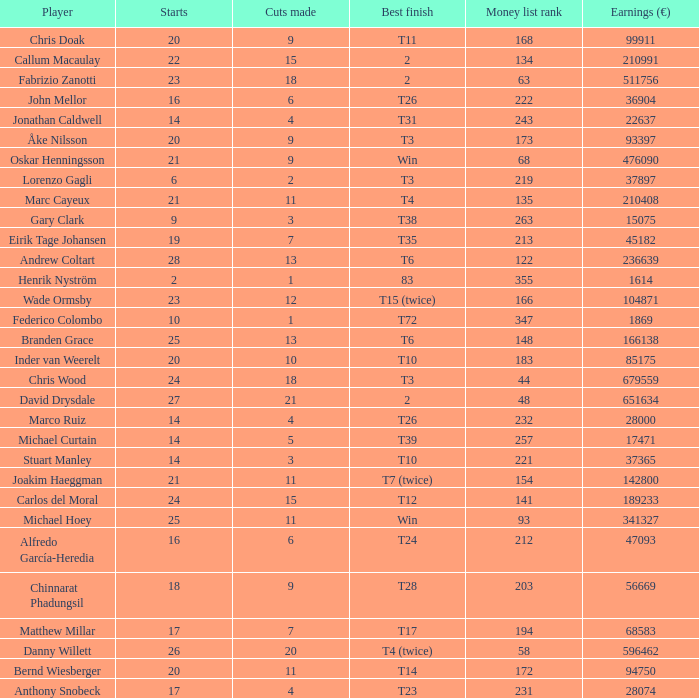How many cuts did Bernd Wiesberger make? 11.0. 